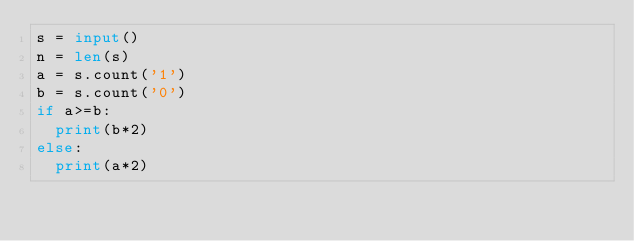<code> <loc_0><loc_0><loc_500><loc_500><_Python_>s = input()
n = len(s)
a = s.count('1')
b = s.count('0')
if a>=b:
  print(b*2)
else:
  print(a*2)</code> 